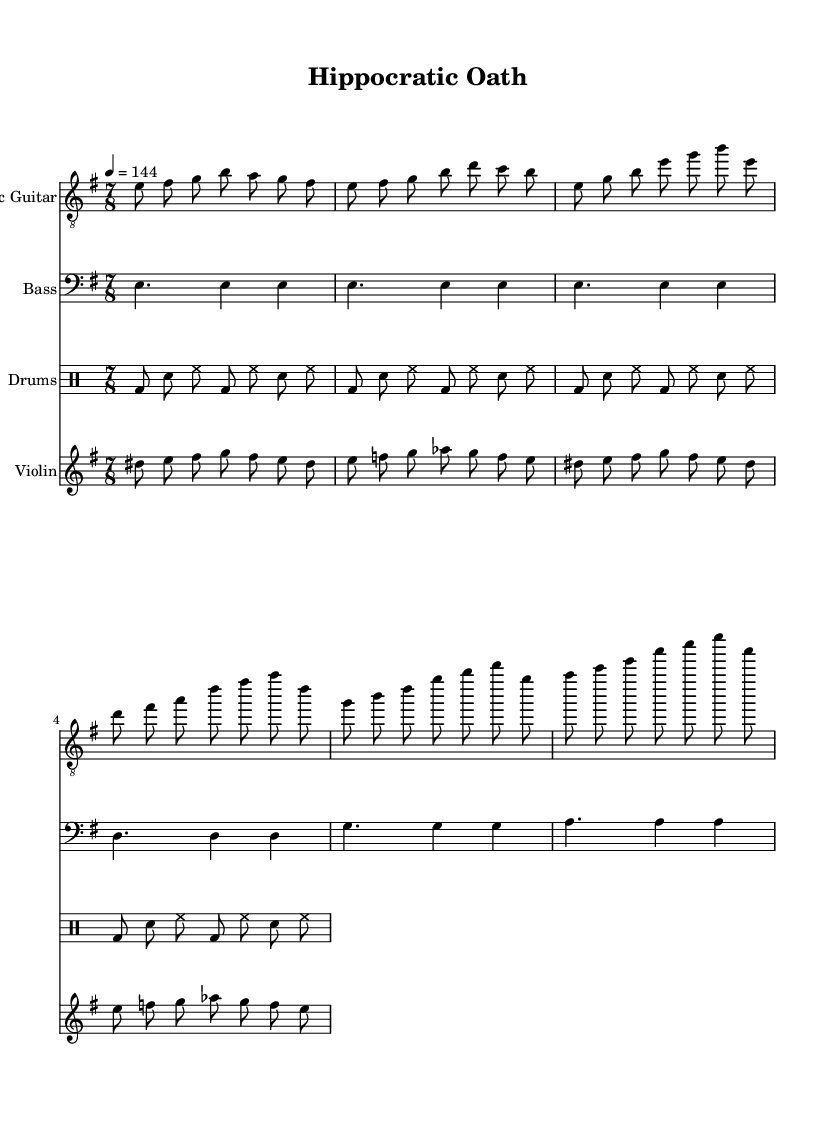What is the key signature of this music? The key signature is E minor, which has one sharp (F#). In the music sheet, the key is indicated at the beginning of the staff.
Answer: E minor What is the time signature of this music? The time signature is 7/8, shown at the beginning of the music. This indicates that there are seven eighth notes per measure.
Answer: 7/8 What is the tempo marking for this music? The tempo marking is 4 equals 144, as noted at the start of the music. This indicates that there should be 144 beats per minute, with each quarter note getting one beat.
Answer: 144 How many measures are in the verse section? The verse section consists of four measures, as indicated by the group of notes that repeat the structure of the verse.
Answer: 4 Which instrument is playing the dissonant part? The dissonant part is played by the violin, as identified by the staff labeled "Violin" and the corresponding notes.
Answer: Violin What is the rhythm pattern of the drums in one measure? The basic rhythm pattern in one measure for the drums consists of the following: bass drum, snare, hi-hat, followed by the same sequence. This pattern includes three eighth notes, one bass drum, and two snare hits per measure.
Answer: bass drum, snare, hi-hat Which section has the chord progression starting on G? The chorus section starts on G as indicated by the notes played in the chorus part of the electric guitar, with G being the initial note in that section.
Answer: Chorus 